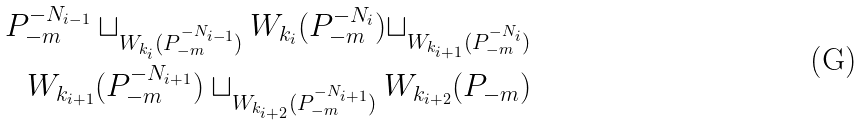Convert formula to latex. <formula><loc_0><loc_0><loc_500><loc_500>P _ { - m } ^ { - N _ { i - 1 } } \sqcup _ { W _ { k _ { i } } ( P _ { - m } ^ { - N _ { i - 1 } } ) } W _ { k _ { i } } ( P _ { - m } ^ { - N _ { i } } ) \sqcup _ { W _ { k _ { i + 1 } } ( P _ { - m } ^ { - N _ { i } } ) } \\ W _ { k _ { i + 1 } } ( P _ { - m } ^ { - N _ { i + 1 } } ) \sqcup _ { W _ { k _ { i + 2 } } ( P _ { - m } ^ { - N _ { i + 1 } } ) } W _ { k _ { i + 2 } } ( P _ { - m } )</formula> 